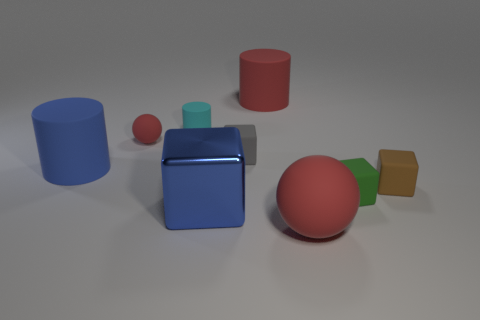Subtract all big cylinders. How many cylinders are left? 1 Subtract 2 cubes. How many cubes are left? 2 Subtract all cyan cylinders. How many cylinders are left? 2 Add 1 green shiny cylinders. How many objects exist? 10 Subtract all spheres. How many objects are left? 7 Subtract all purple cylinders. Subtract all gray balls. How many cylinders are left? 3 Add 2 brown matte things. How many brown matte things are left? 3 Add 2 cyan rubber objects. How many cyan rubber objects exist? 3 Subtract 0 brown balls. How many objects are left? 9 Subtract all brown rubber objects. Subtract all big blue shiny blocks. How many objects are left? 7 